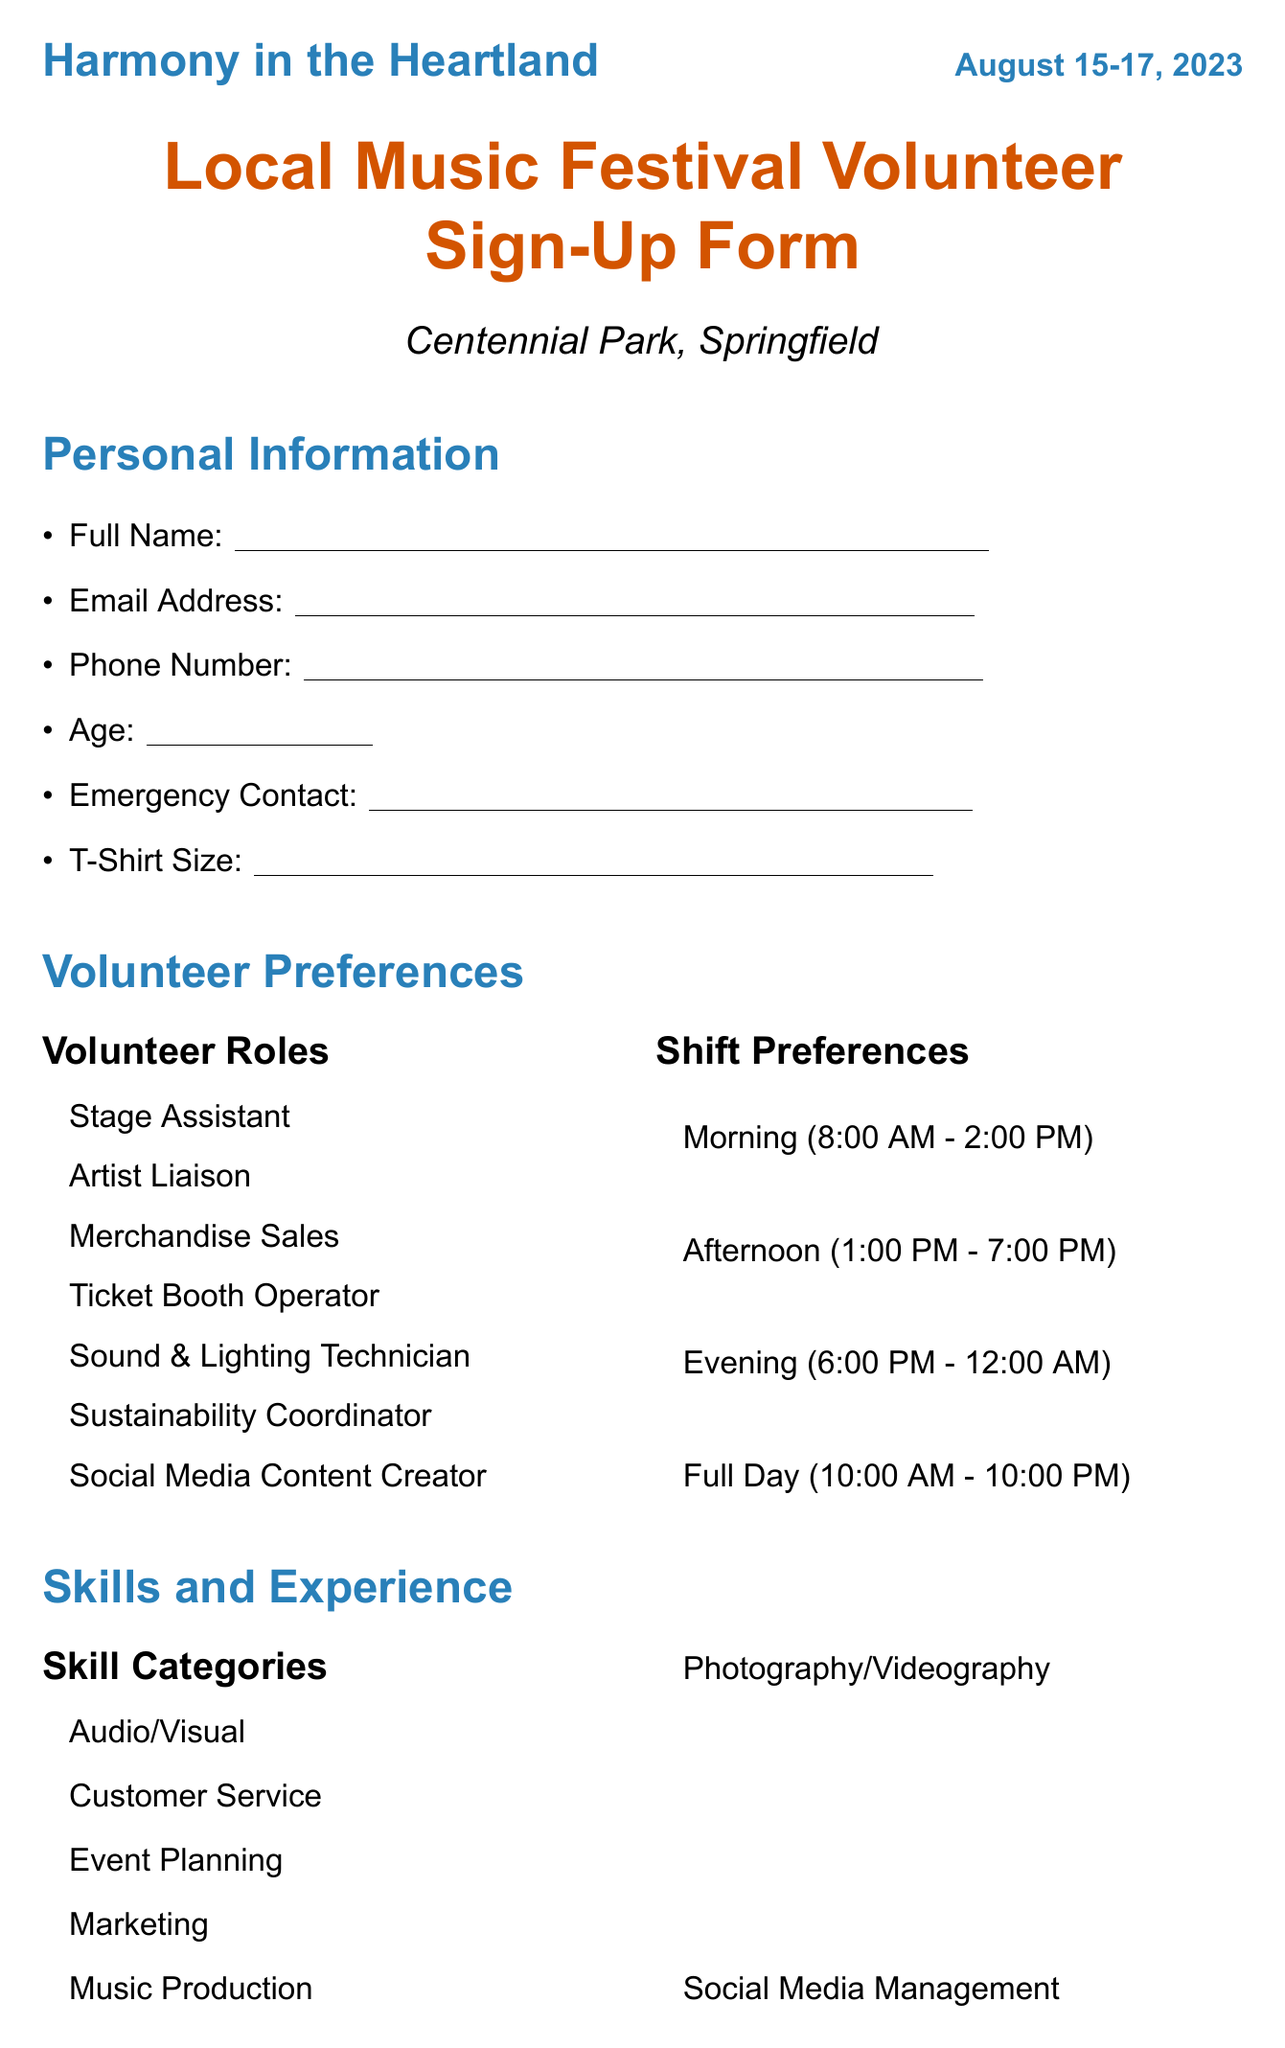What is the name of the festival? The name of the festival is provided at the top of the document.
Answer: Harmony in the Heartland What are the festival dates? The festival dates are listed prominently in the document.
Answer: August 15-17, 2023 Where is the festival located? The location of the festival is indicated in the document.
Answer: Centennial Park, Springfield What volunteer role involves working with artists? The document lists different roles, one of which specifically focuses on artists.
Answer: Artist Liaison Which benefit includes a festival pass? Benefits for volunteers include various rewards, one of which is a free pass to the festival.
Answer: Free festival pass How many shift preferences are listed? The number of shift preferences can be counted from the section in the document.
Answer: Four What skill category is related to social media? The document outlines various skill categories with one directly related to social media.
Answer: Social Media Management What should volunteers provide as part of required information? The document specifies what information volunteers need to supply.
Answer: Full Name What is an example of reasoning regarding local music organizations? The document asks if the volunteer is affiliated with local music organizations, linking interest with community support.
Answer: To support local artists and organizations How does the festival contribute to the local music scene? The document poses a question asking for opinions on the festival's impact, inviting reasoning about local music.
Answer: It promotes and showcases local music talent 